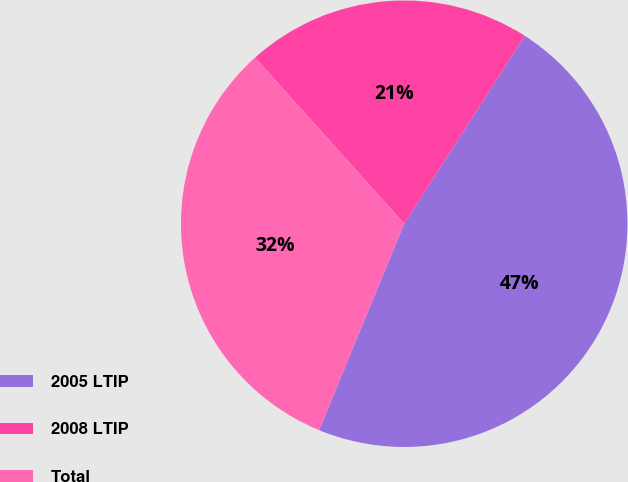Convert chart. <chart><loc_0><loc_0><loc_500><loc_500><pie_chart><fcel>2005 LTIP<fcel>2008 LTIP<fcel>Total<nl><fcel>47.14%<fcel>20.73%<fcel>32.13%<nl></chart> 